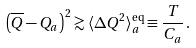<formula> <loc_0><loc_0><loc_500><loc_500>\left ( \overline { Q } - Q _ { a } \right ) ^ { 2 } \gtrsim \langle \Delta Q ^ { 2 } \rangle _ { a } ^ { \text {eq} } \equiv \frac { T } { C _ { a } } \, .</formula> 